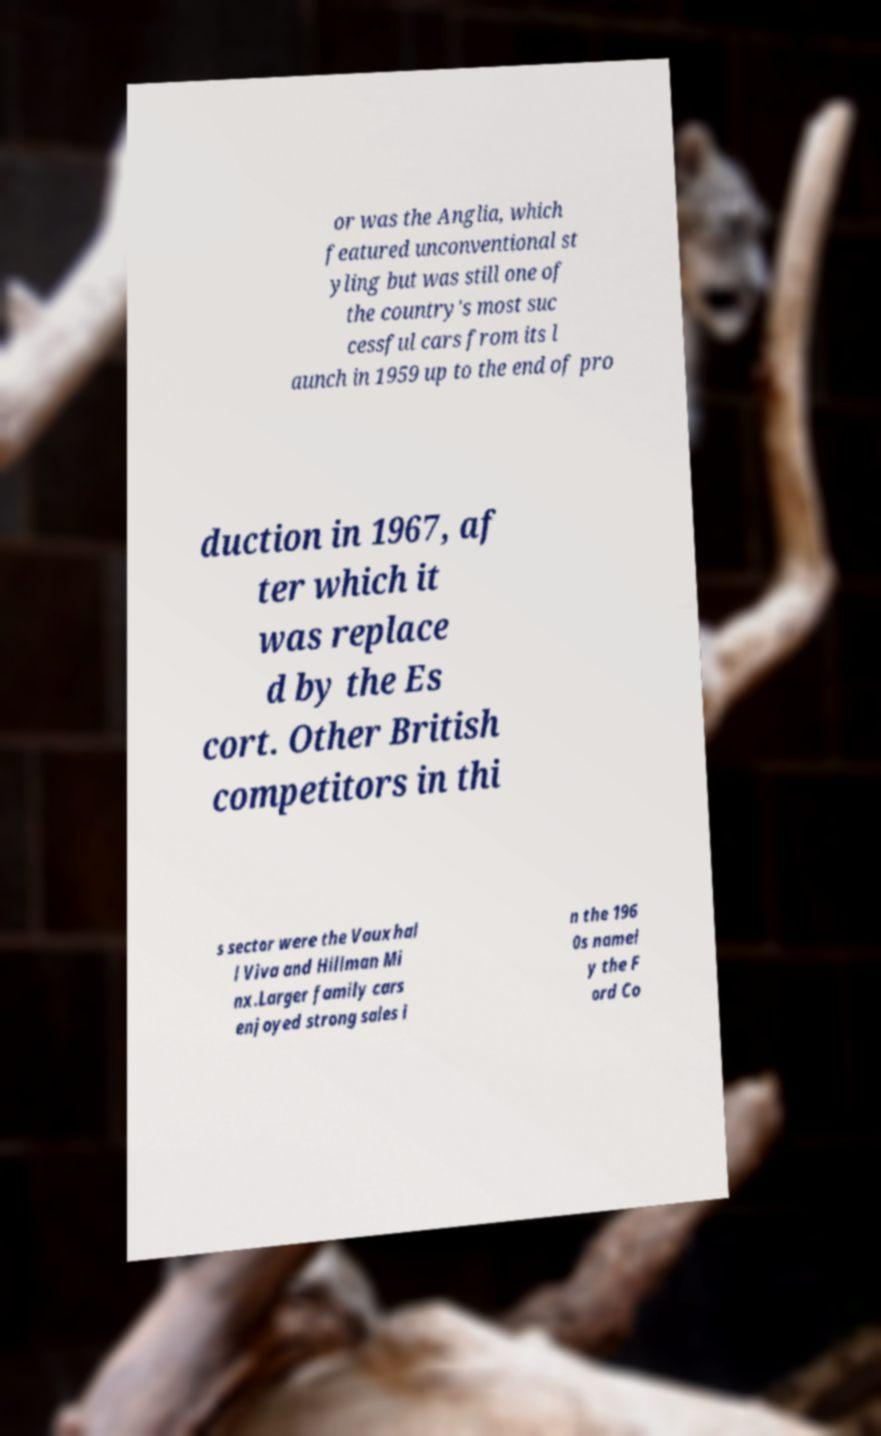Can you read and provide the text displayed in the image?This photo seems to have some interesting text. Can you extract and type it out for me? or was the Anglia, which featured unconventional st yling but was still one of the country's most suc cessful cars from its l aunch in 1959 up to the end of pro duction in 1967, af ter which it was replace d by the Es cort. Other British competitors in thi s sector were the Vauxhal l Viva and Hillman Mi nx.Larger family cars enjoyed strong sales i n the 196 0s namel y the F ord Co 